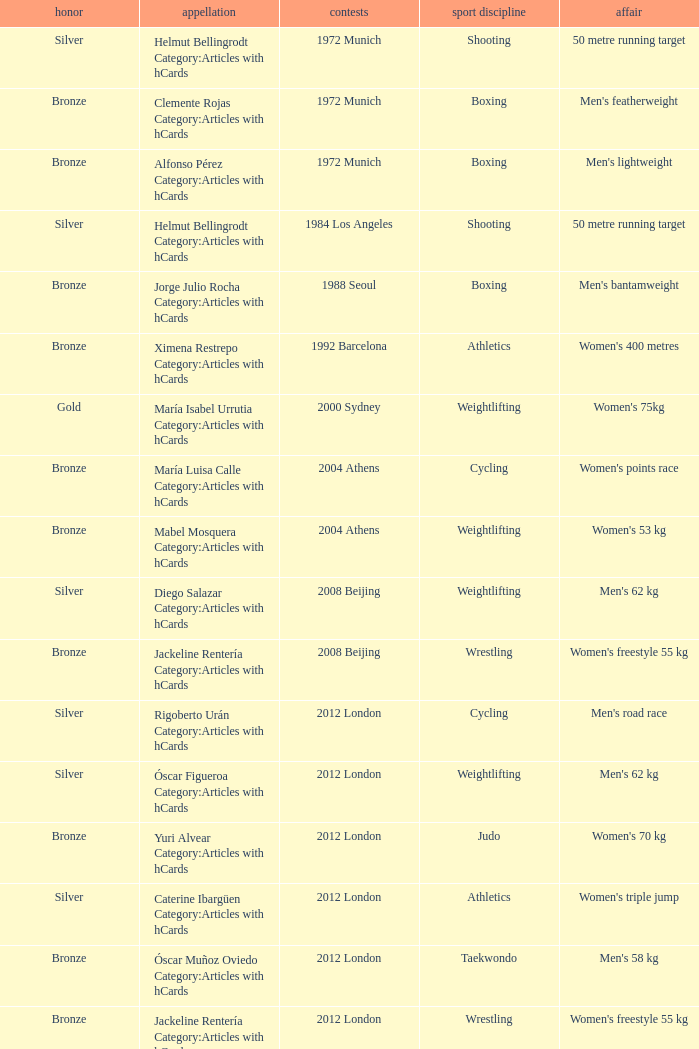Which wrestling event was at the 2008 Beijing games? Women's freestyle 55 kg. 